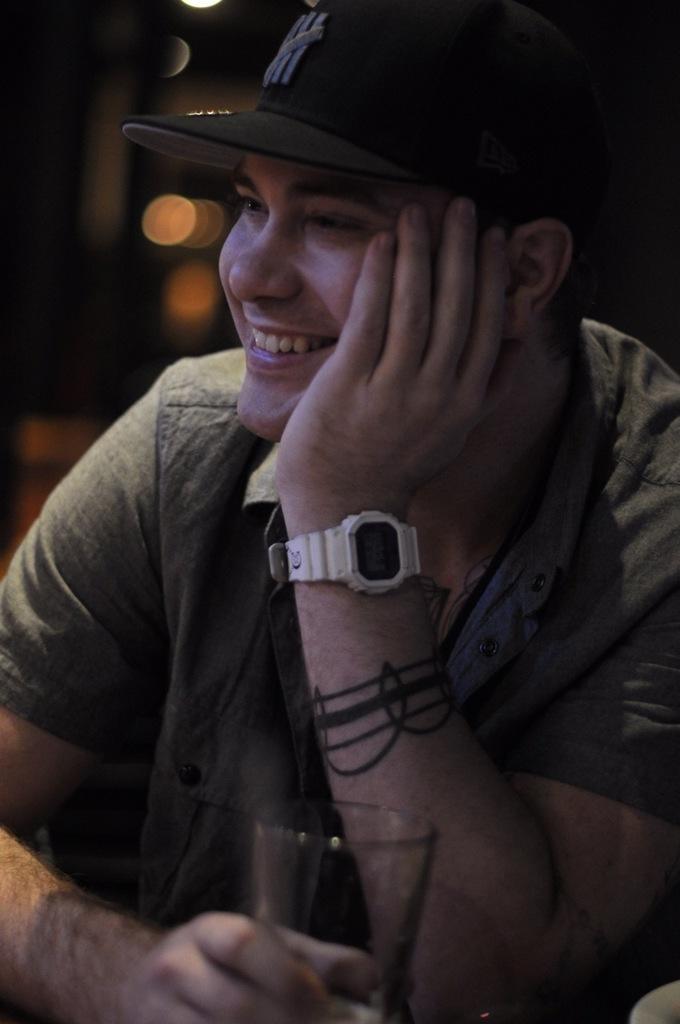Can you describe this image briefly? In this picture we can see a man, he wore a cap and he is smiling, in front of him we can see a glass. 